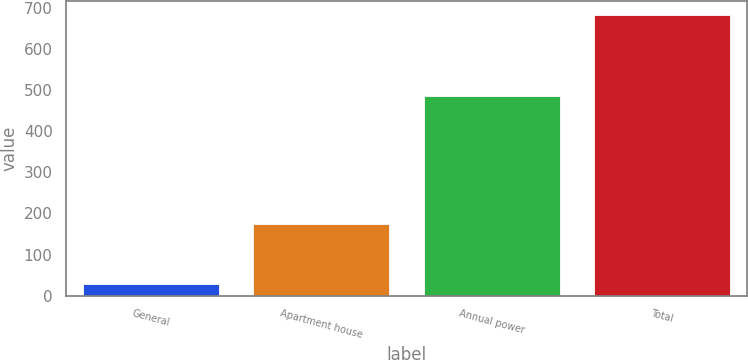<chart> <loc_0><loc_0><loc_500><loc_500><bar_chart><fcel>General<fcel>Apartment house<fcel>Annual power<fcel>Total<nl><fcel>28<fcel>175<fcel>487<fcel>683<nl></chart> 